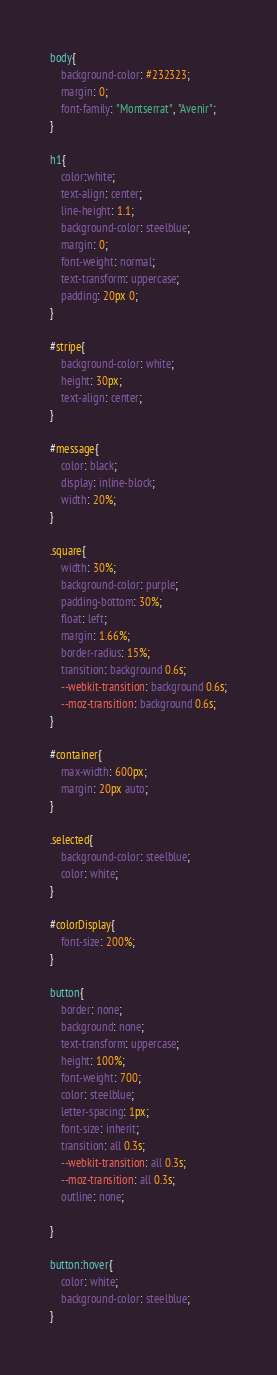Convert code to text. <code><loc_0><loc_0><loc_500><loc_500><_CSS_>body{
	background-color: #232323;
	margin: 0;
	font-family: "Montserrat", "Avenir";
}

h1{
	color:white;
	text-align: center;
	line-height: 1.1;
	background-color: steelblue;
	margin: 0;
	font-weight: normal;
	text-transform: uppercase;
	padding: 20px 0;
}

#stripe{
	background-color: white;
	height: 30px;
	text-align: center;
}

#message{
	color: black;
	display: inline-block;
	width: 20%;
}

.square{
	width: 30%;
	background-color: purple;
	padding-bottom: 30%;
	float: left;
	margin: 1.66%;
	border-radius: 15%;
	transition: background 0.6s;
	--webkit-transition: background 0.6s;
	--moz-transition: background 0.6s;
}

#container{
	max-width: 600px;
	margin: 20px auto;
}

.selected{
	background-color: steelblue;
	color: white;
}

#colorDisplay{
	font-size: 200%;
}

button{
	border: none;
	background: none;
	text-transform: uppercase;
	height: 100%;
	font-weight: 700;
	color: steelblue;
	letter-spacing: 1px;
	font-size: inherit;
	transition: all 0.3s;
	--webkit-transition: all 0.3s;
	--moz-transition: all 0.3s;
	outline: none;

}

button:hover{
	color: white;
	background-color: steelblue;
}

</code> 